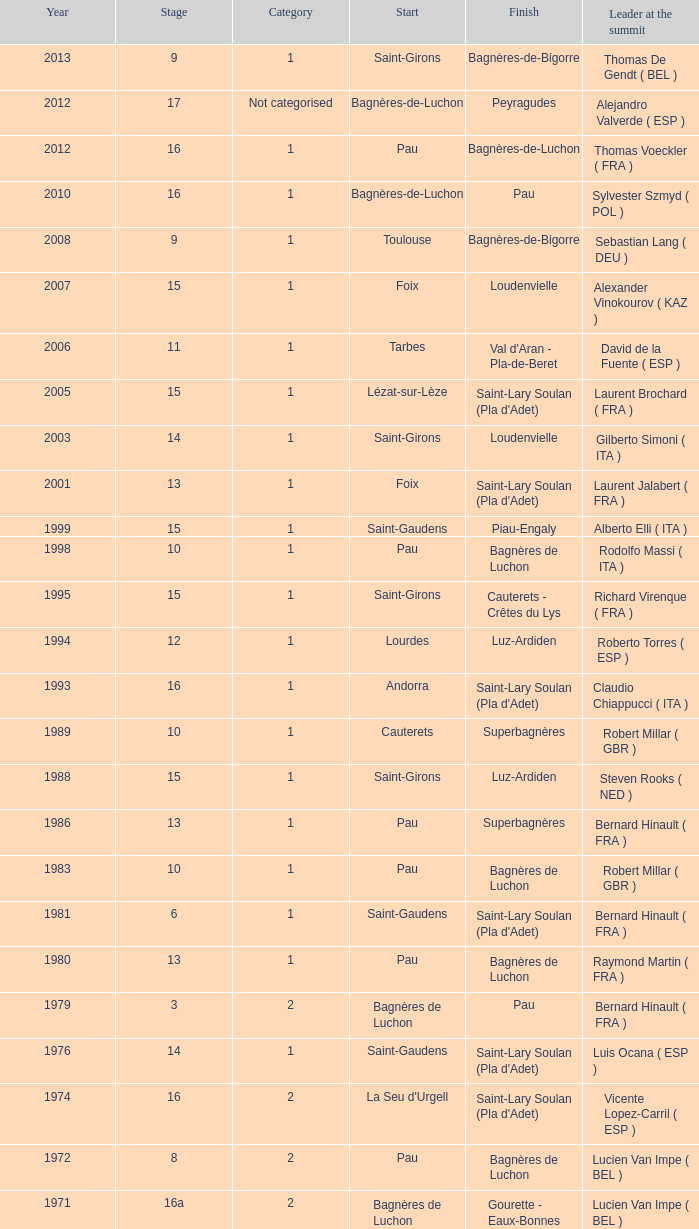What category was in 1964? 2.0. I'm looking to parse the entire table for insights. Could you assist me with that? {'header': ['Year', 'Stage', 'Category', 'Start', 'Finish', 'Leader at the summit'], 'rows': [['2013', '9', '1', 'Saint-Girons', 'Bagnères-de-Bigorre', 'Thomas De Gendt ( BEL )'], ['2012', '17', 'Not categorised', 'Bagnères-de-Luchon', 'Peyragudes', 'Alejandro Valverde ( ESP )'], ['2012', '16', '1', 'Pau', 'Bagnères-de-Luchon', 'Thomas Voeckler ( FRA )'], ['2010', '16', '1', 'Bagnères-de-Luchon', 'Pau', 'Sylvester Szmyd ( POL )'], ['2008', '9', '1', 'Toulouse', 'Bagnères-de-Bigorre', 'Sebastian Lang ( DEU )'], ['2007', '15', '1', 'Foix', 'Loudenvielle', 'Alexander Vinokourov ( KAZ )'], ['2006', '11', '1', 'Tarbes', "Val d'Aran - Pla-de-Beret", 'David de la Fuente ( ESP )'], ['2005', '15', '1', 'Lézat-sur-Lèze', "Saint-Lary Soulan (Pla d'Adet)", 'Laurent Brochard ( FRA )'], ['2003', '14', '1', 'Saint-Girons', 'Loudenvielle', 'Gilberto Simoni ( ITA )'], ['2001', '13', '1', 'Foix', "Saint-Lary Soulan (Pla d'Adet)", 'Laurent Jalabert ( FRA )'], ['1999', '15', '1', 'Saint-Gaudens', 'Piau-Engaly', 'Alberto Elli ( ITA )'], ['1998', '10', '1', 'Pau', 'Bagnères de Luchon', 'Rodolfo Massi ( ITA )'], ['1995', '15', '1', 'Saint-Girons', 'Cauterets - Crêtes du Lys', 'Richard Virenque ( FRA )'], ['1994', '12', '1', 'Lourdes', 'Luz-Ardiden', 'Roberto Torres ( ESP )'], ['1993', '16', '1', 'Andorra', "Saint-Lary Soulan (Pla d'Adet)", 'Claudio Chiappucci ( ITA )'], ['1989', '10', '1', 'Cauterets', 'Superbagnères', 'Robert Millar ( GBR )'], ['1988', '15', '1', 'Saint-Girons', 'Luz-Ardiden', 'Steven Rooks ( NED )'], ['1986', '13', '1', 'Pau', 'Superbagnères', 'Bernard Hinault ( FRA )'], ['1983', '10', '1', 'Pau', 'Bagnères de Luchon', 'Robert Millar ( GBR )'], ['1981', '6', '1', 'Saint-Gaudens', "Saint-Lary Soulan (Pla d'Adet)", 'Bernard Hinault ( FRA )'], ['1980', '13', '1', 'Pau', 'Bagnères de Luchon', 'Raymond Martin ( FRA )'], ['1979', '3', '2', 'Bagnères de Luchon', 'Pau', 'Bernard Hinault ( FRA )'], ['1976', '14', '1', 'Saint-Gaudens', "Saint-Lary Soulan (Pla d'Adet)", 'Luis Ocana ( ESP )'], ['1974', '16', '2', "La Seu d'Urgell", "Saint-Lary Soulan (Pla d'Adet)", 'Vicente Lopez-Carril ( ESP )'], ['1972', '8', '2', 'Pau', 'Bagnères de Luchon', 'Lucien Van Impe ( BEL )'], ['1971', '16a', '2', 'Bagnères de Luchon', 'Gourette - Eaux-Bonnes', 'Lucien Van Impe ( BEL )'], ['1970', '18', '2', 'Saint-Gaudens', 'La Mongie', 'Raymond Delisle ( FRA )'], ['1969', '17', '2', 'La Mongie', 'Mourenx', 'Joaquim Galera ( ESP )'], ['1964', '16', '2', 'Bagnères de Luchon', 'Pau', 'Julio Jiménez ( ESP )'], ['1963', '11', '2', 'Bagnères-de-Bigorre', 'Bagnères de Luchon', 'Federico Bahamontes ( ESP )'], ['1962', '12', '2', 'Pau', 'Saint-Gaudens', 'Federico Bahamontes ( ESP )'], ['1961', '17', '2', 'Bagnères de Luchon', 'Pau', 'Imerio Massignan ( ITA )'], ['1960', '11', '1', 'Pau', 'Bagnères de Luchon', 'Kurt Gimmi ( SUI )'], ['1959', '11', '1', 'Bagnères-de-Bigorre', 'Saint-Gaudens', 'Valentin Huot ( FRA )'], ['1958', '14', '1', 'Pau', 'Bagnères de Luchon', 'Federico Bahamontes ( ESP )'], ['1956', '12', 'Not categorised', 'Pau', 'Bagnères de Luchon', 'Jean-Pierre Schmitz ( LUX )'], ['1955', '17', '2', 'Toulouse', 'Saint-Gaudens', 'Charly Gaul ( LUX )'], ['1954', '12', '2', 'Pau', 'Bagnères de Luchon', 'Federico Bahamontes ( ESP )'], ['1953', '11', '2', 'Cauterets', 'Bagnères de Luchon', 'Jean Robic ( FRA )'], ['1952', '17', '2', 'Toulouse', 'Bagnères-de-Bigorre', 'Antonio Gelabert ( ESP )'], ['1951', '14', '2', 'Tarbes', 'Bagnères de Luchon', 'Fausto Coppi ( ITA )'], ['1949', '11', '2', 'Pau', 'Bagnères de Luchon', 'Jean Robic ( FRA )'], ['1948', '8', '2', 'Lourdes', 'Toulouse', 'Jean Robic ( FRA )'], ['1947', '15', '1', 'Bagnères de Luchon', 'Pau', 'Jean Robic ( FRA )']]} 